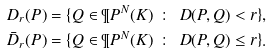Convert formula to latex. <formula><loc_0><loc_0><loc_500><loc_500>D _ { r } ( P ) & = \{ Q \in \P P ^ { N } ( K ) \ \, \colon \, \ D ( P , Q ) < r \} , \\ \bar { D } _ { r } ( P ) & = \{ Q \in \P P ^ { N } ( K ) \ \, \colon \, \ D ( P , Q ) \leq r \} .</formula> 